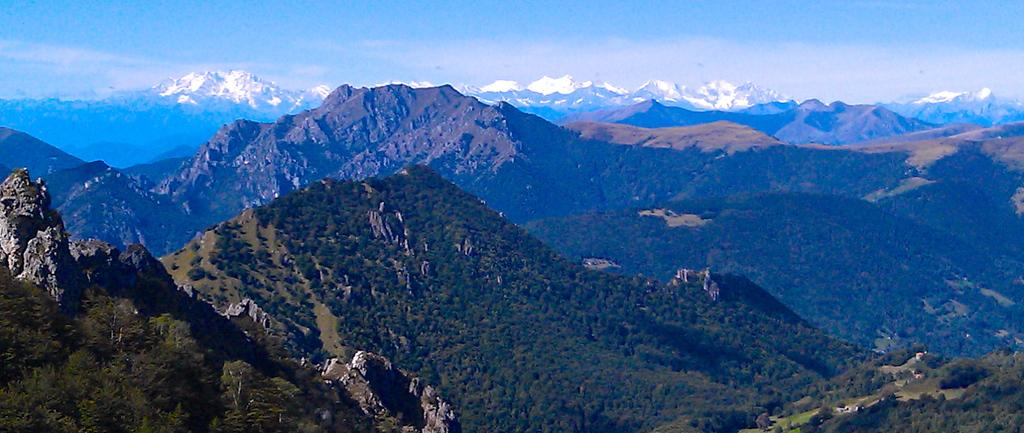What type of geographical feature is present in the image? There are mountains in the image. What is visible at the top of the image? The sky is visible at the top of the image. What type of breakfast is being served on the table in the image? There is no table or breakfast present in the image; it only features mountains and the sky. How many baby cows can be seen grazing in the mountains in the image? There are no cows, baby or otherwise, present in the image; it only features mountains and the sky. 